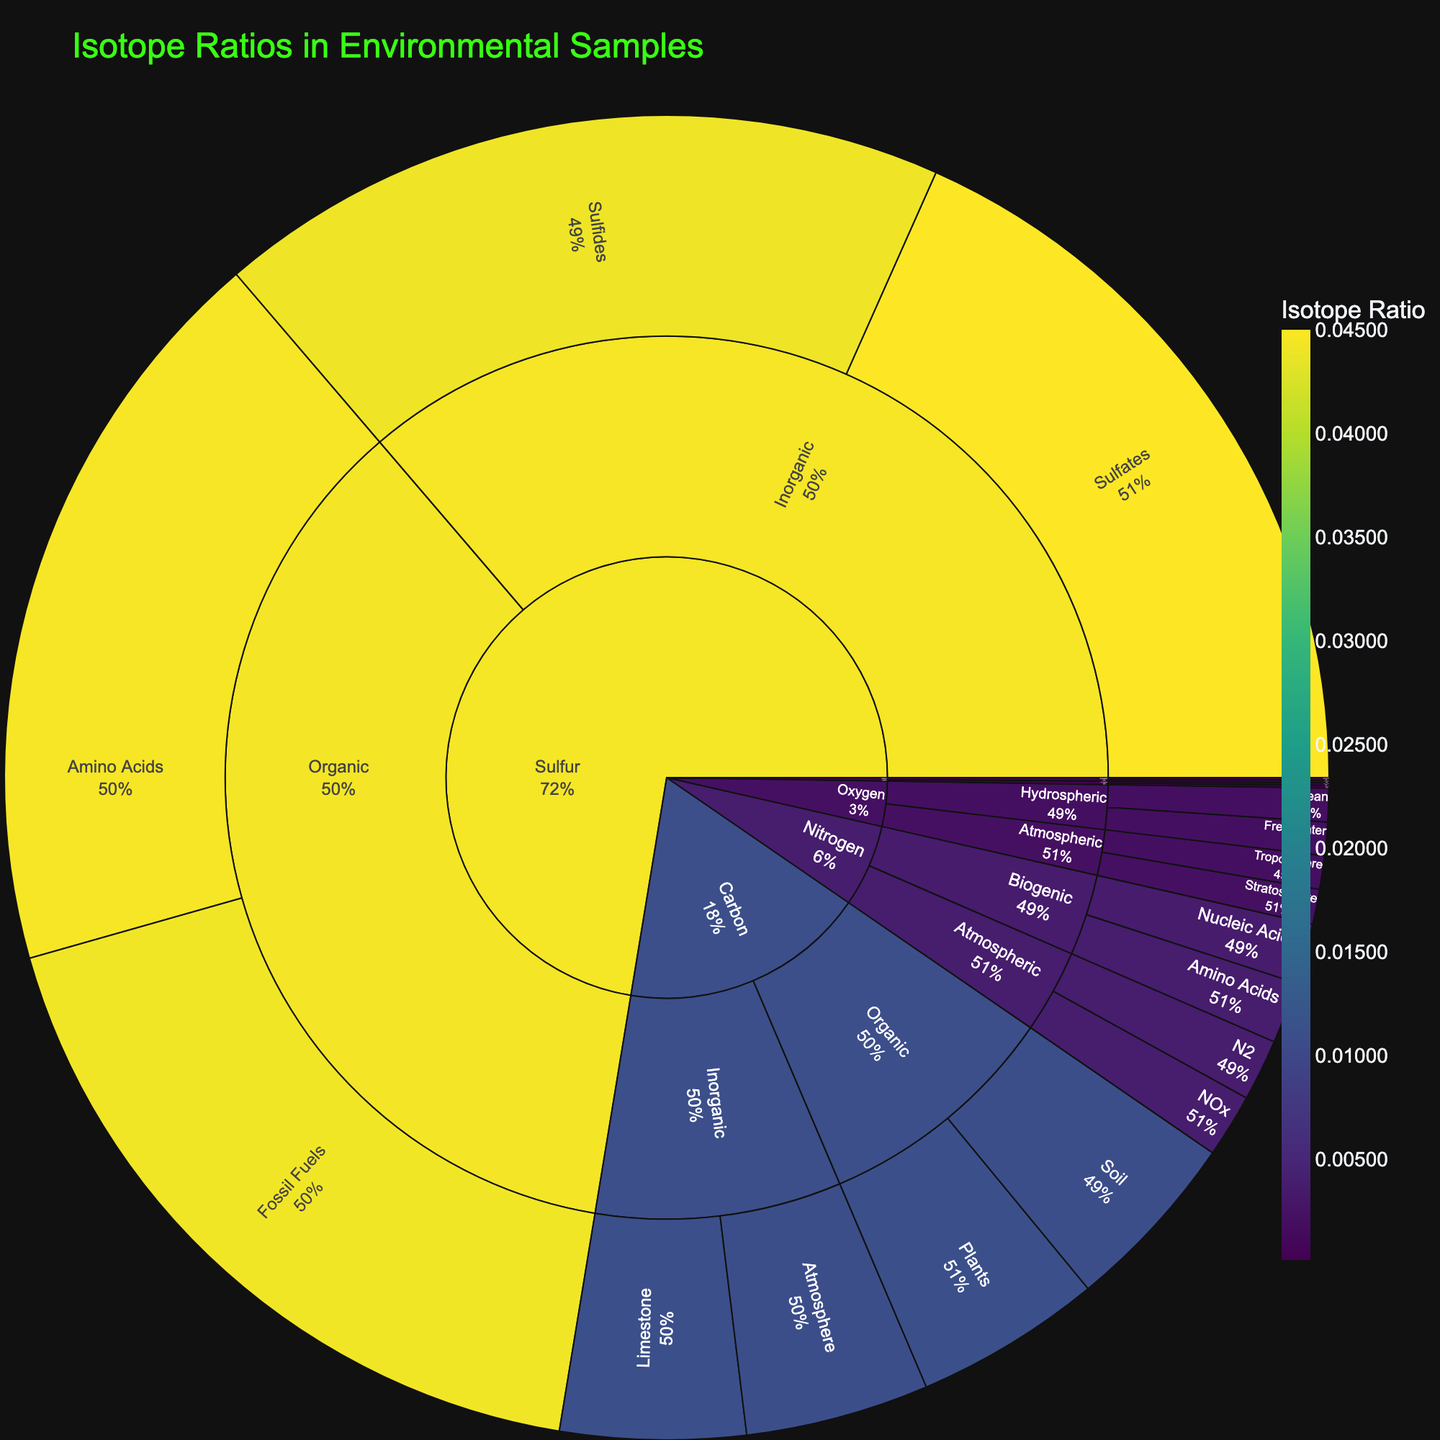What is the title of the figure? Identify the text displayed at the top of the figure. The title is usually prominently placed to describe the content.
Answer: Isotope Ratios in Environmental Samples Which element has the highest isotope ratio in its data points? Examine the color intensity and the values of isotope ratios for each element. The highest color intensity and numeric value indicate the highest isotope ratio.
Answer: Sulfur What is the isotope ratio for Carbon in inorganic groups? Find the subgroup under the Carbon element where it is classified as "Inorganic" and note down the isotope ratios provided.
Answer: 0.0111 for Limestone, 0.0110 for Atmosphere How many subgroups are there under the Oxygen element? Count the number of segments under the Oxygen element. Each segment represents a subgroup.
Answer: 4 Which subgroup of Sulfur has the isotope ratio of 0.0445? Look for the Sulfur element and identify the subgroup with the indicated isotope ratio.
Answer: Amino Acids What is the sum of isotope ratios for Nitrogen in the Atmospheric group? Add the isotope ratios of subgroups N2 and NOx under the Atmospheric group within the Nitrogen element. (0.0037 + 0.0038)
Answer: 0.0075 Which element's subgroup has the lowest isotope ratio, and what is it? Identify the group and subgroup with the lowest isotope ratio by examining the values or least intense color.
Answer: Hydrogen, Atmospheric, Water Vapor (0.00015) Compare the isotope ratios of Organic and Inorganic groups under Sulfur. Which group has a higher average isotope ratio? Calculate the average isotope ratio for Organic (0.0445 + 0.0442) / 2 and Inorganic (0.0450 + 0.0440) / 2 groups under Sulfur, then compare.
Answer: Inorganic (0.0445 vs. 0.04435) What percentage of the total isotope ratio is contributed by the Troposphere subgroup of Oxygen? Find the ratio of the Troposphere's isotope ratio (0.0020) to the total isotope ratios for all Oxygen subgroups, then convert to percentage. [(0.0020) / (0.0020 + 0.0021 + 0.0020 + 0.0020)] x 100
Answer: 25% How does the isotope ratio of Seawater compare to Groundwater within the Hydrogen element? Identify the isotope ratios for Seawater (0.00016) and Groundwater (0.00015) under the Hydrogen element and compare.
Answer: Seawater is higher 